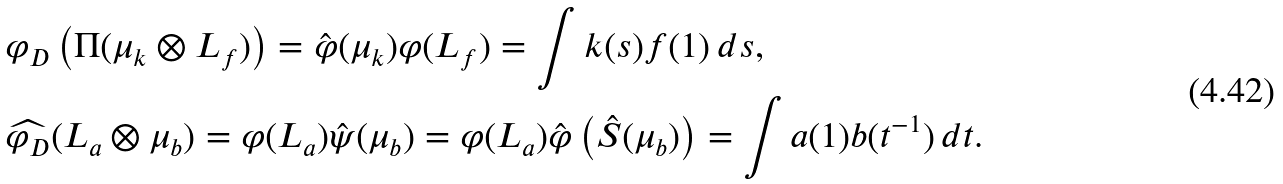Convert formula to latex. <formula><loc_0><loc_0><loc_500><loc_500>& \varphi _ { D } \left ( \Pi ( \mu _ { k } \otimes L _ { f } ) \right ) = \hat { \varphi } ( \mu _ { k } ) \varphi ( L _ { f } ) = \int k ( s ) f ( 1 ) \, d s , \\ & \widehat { \varphi _ { D } } ( L _ { a } \otimes \mu _ { b } ) = \varphi ( L _ { a } ) \hat { \psi } ( \mu _ { b } ) = \varphi ( L _ { a } ) \hat { \varphi } \left ( \hat { S } ( \mu _ { b } ) \right ) = \int a ( 1 ) b ( t ^ { - 1 } ) \, d t .</formula> 